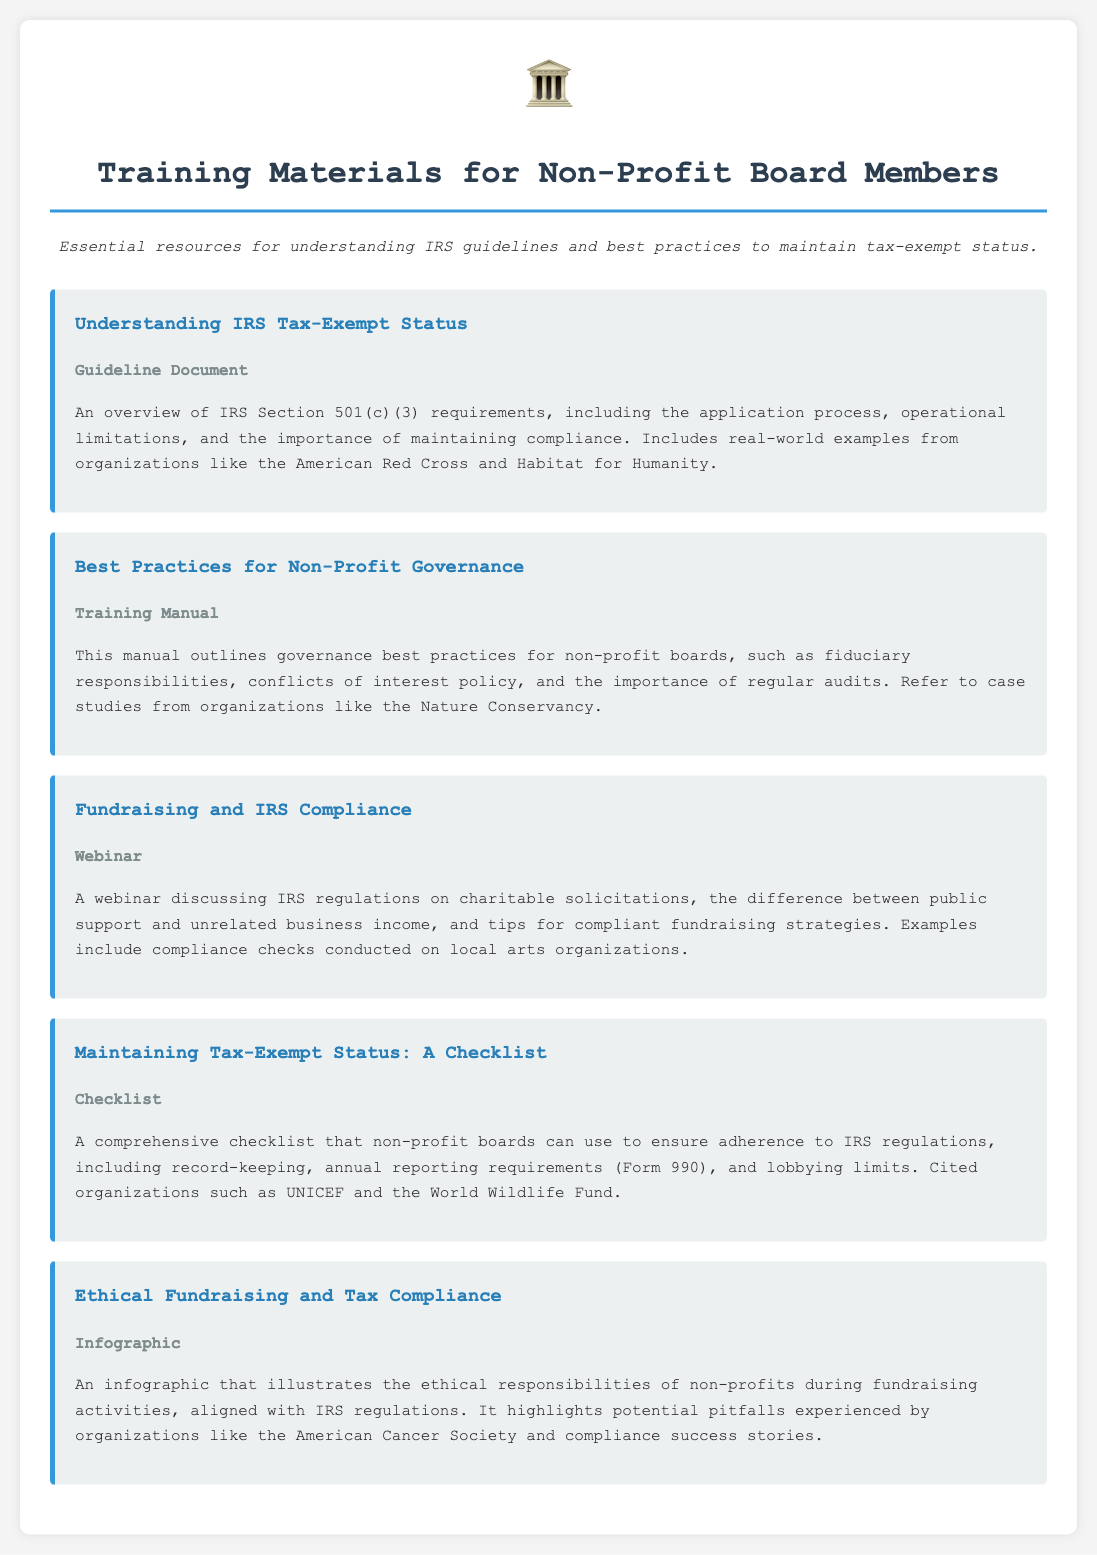What is the title of the first training material? The first training material is titled "Understanding IRS Tax-Exempt Status."
Answer: Understanding IRS Tax-Exempt Status What type of document is "Best Practices for Non-Profit Governance"? "Best Practices for Non-Profit Governance" is categorized as a Training Manual.
Answer: Training Manual Which organization is cited in the "Fundraising and IRS Compliance" webinar? The document mentions compliance checks conducted on local arts organizations as cited in the webinar.
Answer: Local arts organizations What is included in the "Maintaining Tax-Exempt Status: A Checklist"? The checklist includes record-keeping, annual reporting requirements, and lobbying limits among other IRS regulations.
Answer: Record-keeping, annual reporting requirements, and lobbying limits How many training materials are listed in the document? The document lists a total of five training materials for non-profit board members.
Answer: Five Which material is presented as an infographic? The material titled "Ethical Fundraising and Tax Compliance" is presented as an infographic.
Answer: Ethical Fundraising and Tax Compliance What is the main focus of the "Understanding IRS Tax-Exempt Status"? The main focus is on IRS Section 501(c)(3) requirements and compliance.
Answer: IRS Section 501(c)(3) requirements and compliance What is the color associated with headings in the document? The headings in the document are styled with the color #2980b9.
Answer: #2980b9 